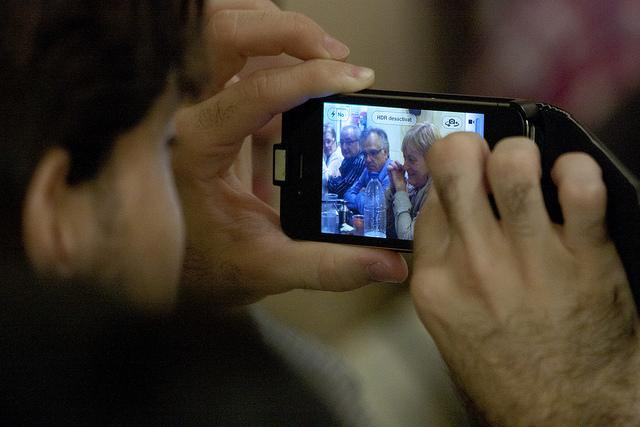Which is magnifying or moving towards yourself the photography is called? zoom 